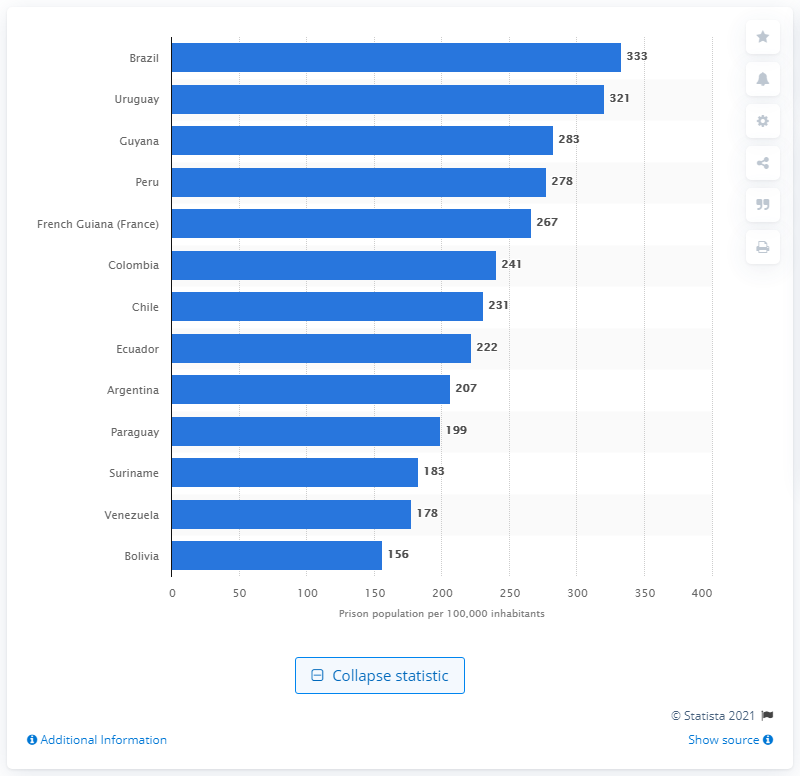Highlight a few significant elements in this photo. Uruguay has the highest prison population rate among South American countries. Brazil has the highest prison population rate among all countries. 